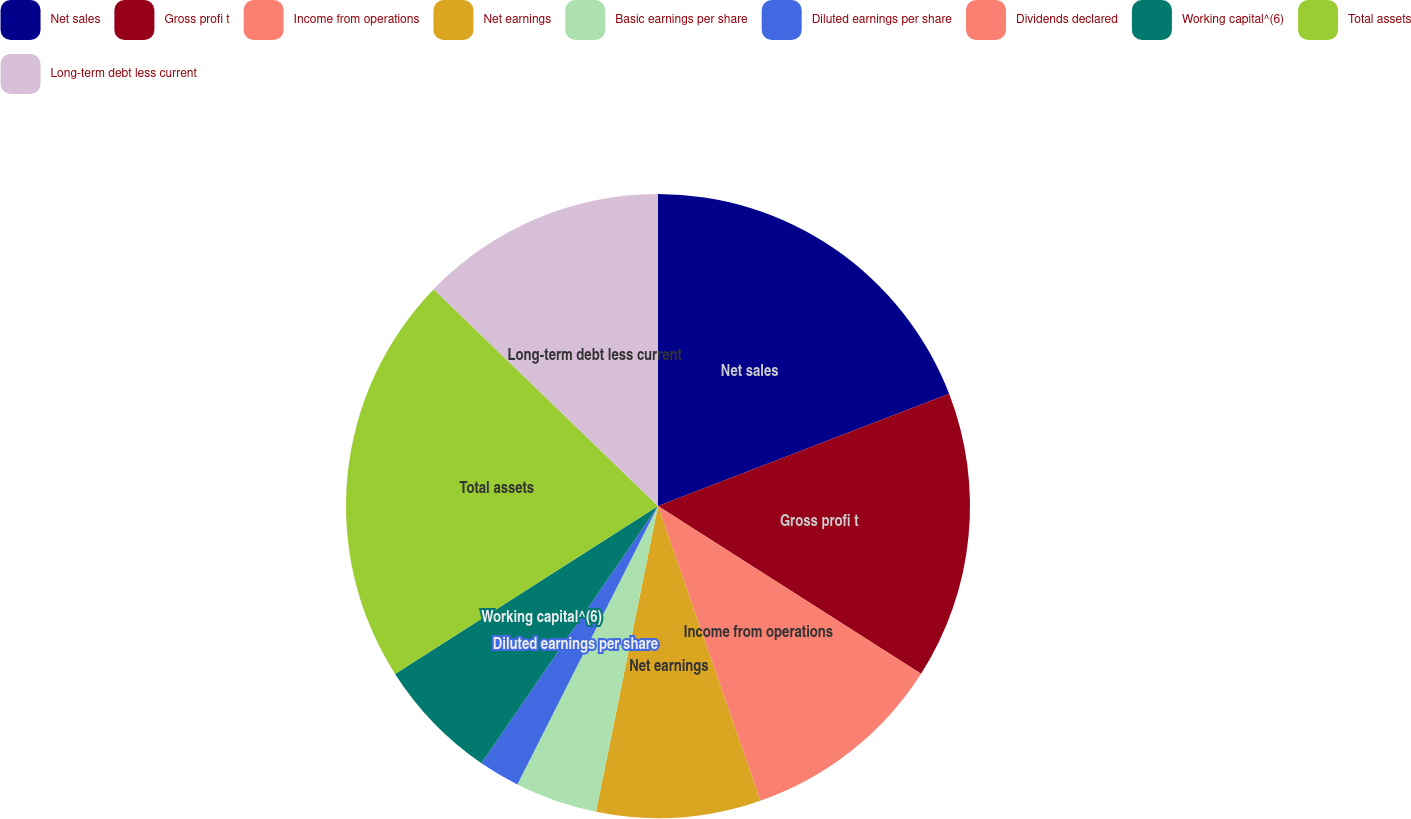Convert chart. <chart><loc_0><loc_0><loc_500><loc_500><pie_chart><fcel>Net sales<fcel>Gross profi t<fcel>Income from operations<fcel>Net earnings<fcel>Basic earnings per share<fcel>Diluted earnings per share<fcel>Dividends declared<fcel>Working capital^(6)<fcel>Total assets<fcel>Long-term debt less current<nl><fcel>19.15%<fcel>14.89%<fcel>10.64%<fcel>8.51%<fcel>4.26%<fcel>2.13%<fcel>0.0%<fcel>6.38%<fcel>21.28%<fcel>12.77%<nl></chart> 